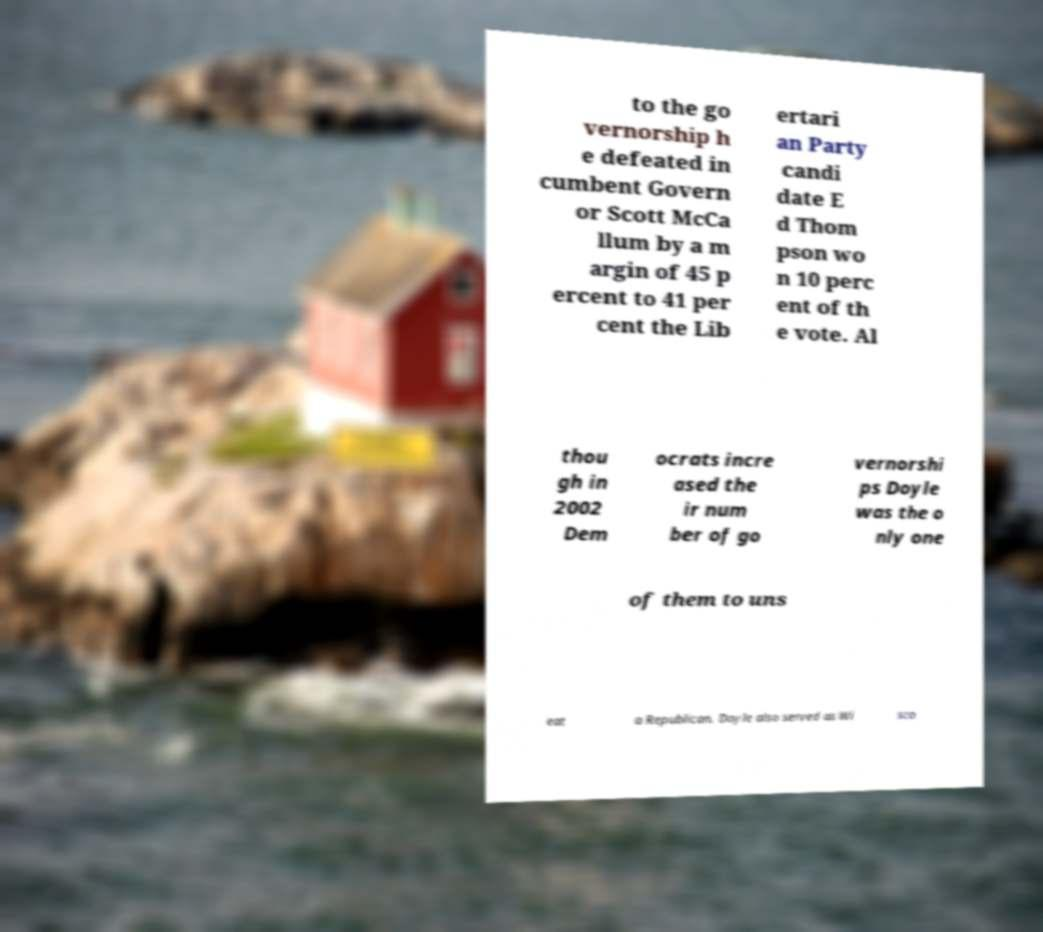Please read and relay the text visible in this image. What does it say? to the go vernorship h e defeated in cumbent Govern or Scott McCa llum by a m argin of 45 p ercent to 41 per cent the Lib ertari an Party candi date E d Thom pson wo n 10 perc ent of th e vote. Al thou gh in 2002 Dem ocrats incre ased the ir num ber of go vernorshi ps Doyle was the o nly one of them to uns eat a Republican. Doyle also served as Wi sco 